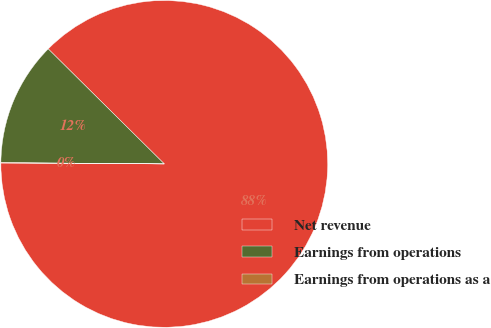Convert chart to OTSL. <chart><loc_0><loc_0><loc_500><loc_500><pie_chart><fcel>Net revenue<fcel>Earnings from operations<fcel>Earnings from operations as a<nl><fcel>87.66%<fcel>12.3%<fcel>0.04%<nl></chart> 